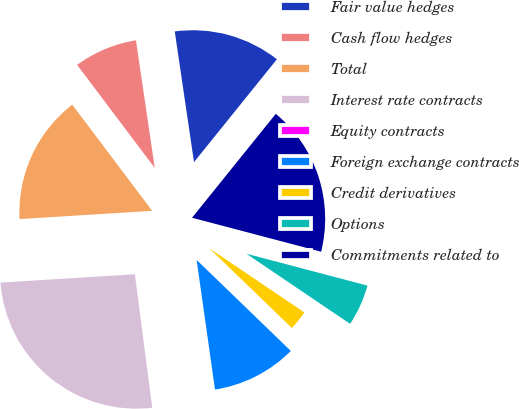Convert chart to OTSL. <chart><loc_0><loc_0><loc_500><loc_500><pie_chart><fcel>Fair value hedges<fcel>Cash flow hedges<fcel>Total<fcel>Interest rate contracts<fcel>Equity contracts<fcel>Foreign exchange contracts<fcel>Credit derivatives<fcel>Options<fcel>Commitments related to<nl><fcel>13.13%<fcel>7.95%<fcel>15.72%<fcel>26.08%<fcel>0.18%<fcel>10.54%<fcel>2.77%<fcel>5.36%<fcel>18.31%<nl></chart> 